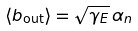Convert formula to latex. <formula><loc_0><loc_0><loc_500><loc_500>\langle b _ { \text {out} } \rangle = \sqrt { \gamma _ { E } } \, \alpha _ { n }</formula> 